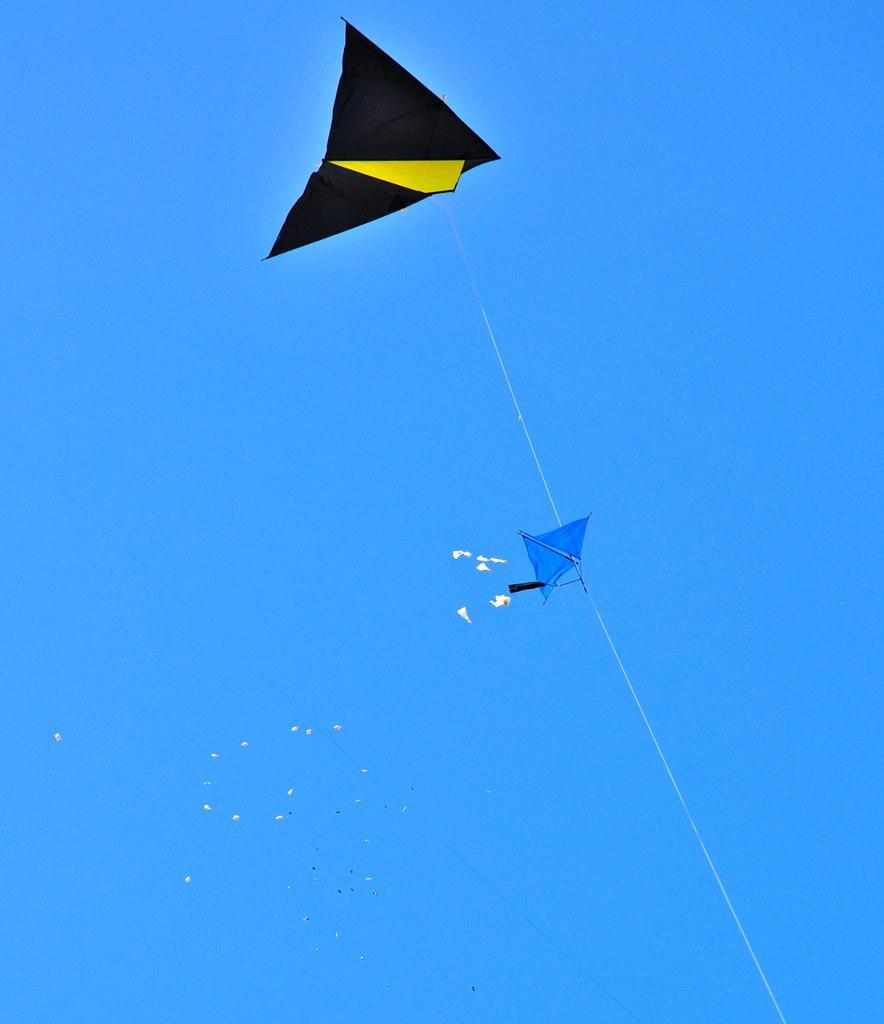What is happening in the sky in the image? There are kites flying in the sky in the image. Can you describe the appearance of the kites? The provided facts do not give a detailed description of the kites' appearance. What might be the occasion for flying kites in the image? The provided facts do not give information about the occasion or reason for flying kites. Where is the basin located in the image? There is no basin present in the image; it only features kites flying in the sky. 